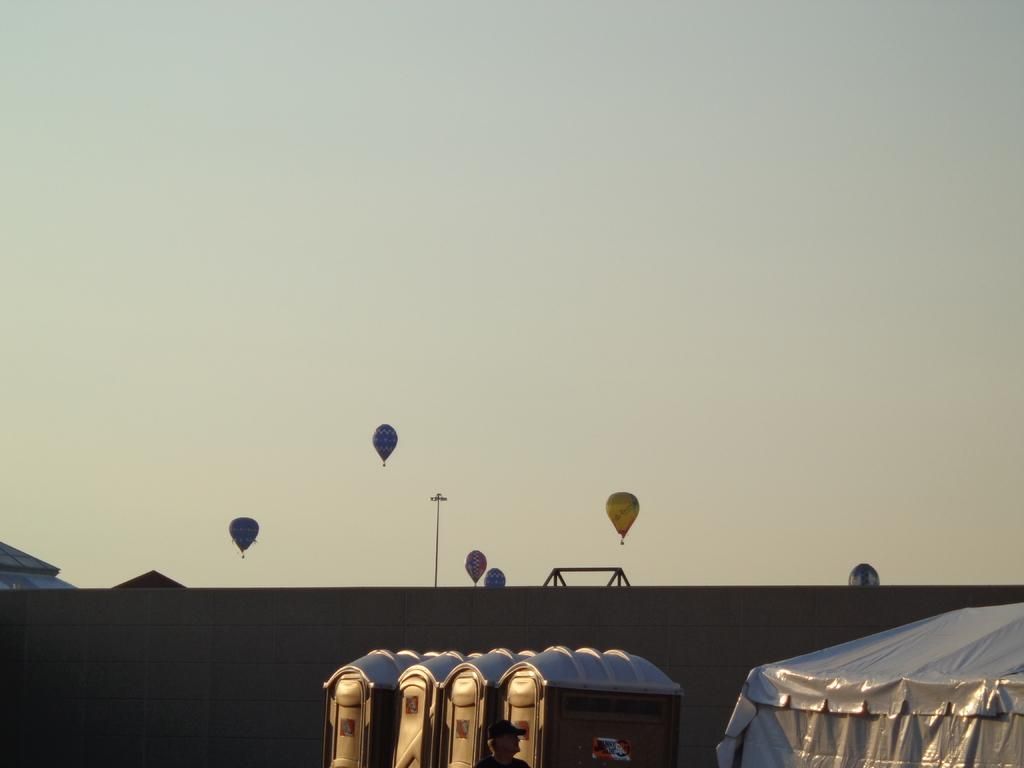What type of shelter is present in the image? There is a tent in the image. What is the person in the image doing? A person wearing a cap is walking in the image. Are there any facilities for public use in the image? Yes, there are public toilets in the image. What else can be seen in the sky besides the plain background? Air balloons are visible in the air. What is a tall structure with a light source in the image? There is a light pole in the image. Can you see the person's smile in the image? There is no information about the person's facial expression in the image, so we cannot determine if they are smiling or not. Is this image a print of a vacation destination? The image itself is not described as a print, and there is no information about it being a vacation destination. 